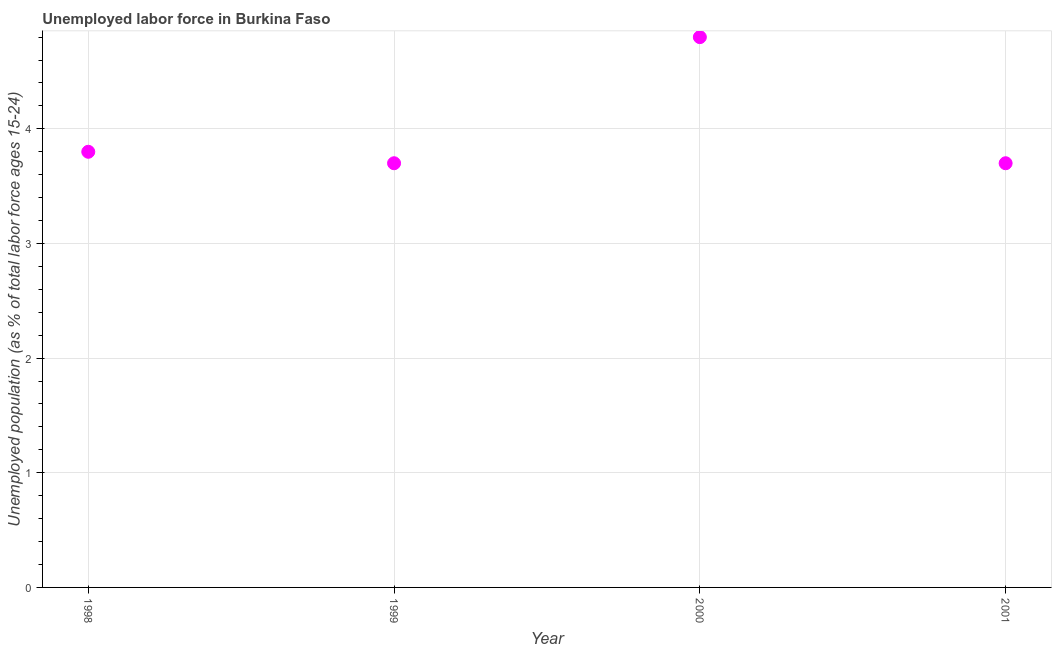What is the total unemployed youth population in 1998?
Keep it short and to the point. 3.8. Across all years, what is the maximum total unemployed youth population?
Offer a terse response. 4.8. Across all years, what is the minimum total unemployed youth population?
Your answer should be very brief. 3.7. In which year was the total unemployed youth population maximum?
Offer a very short reply. 2000. In which year was the total unemployed youth population minimum?
Ensure brevity in your answer.  1999. What is the sum of the total unemployed youth population?
Provide a short and direct response. 16. What is the average total unemployed youth population per year?
Ensure brevity in your answer.  4. What is the median total unemployed youth population?
Ensure brevity in your answer.  3.75. In how many years, is the total unemployed youth population greater than 0.6000000000000001 %?
Your response must be concise. 4. Do a majority of the years between 2001 and 1998 (inclusive) have total unemployed youth population greater than 1 %?
Provide a short and direct response. Yes. What is the ratio of the total unemployed youth population in 2000 to that in 2001?
Provide a short and direct response. 1.3. Is the difference between the total unemployed youth population in 1998 and 2001 greater than the difference between any two years?
Your response must be concise. No. What is the difference between the highest and the second highest total unemployed youth population?
Make the answer very short. 1. What is the difference between the highest and the lowest total unemployed youth population?
Your answer should be very brief. 1.1. How many dotlines are there?
Your answer should be very brief. 1. How many years are there in the graph?
Your response must be concise. 4. What is the difference between two consecutive major ticks on the Y-axis?
Offer a very short reply. 1. Does the graph contain any zero values?
Offer a terse response. No. Does the graph contain grids?
Your response must be concise. Yes. What is the title of the graph?
Provide a succinct answer. Unemployed labor force in Burkina Faso. What is the label or title of the Y-axis?
Offer a terse response. Unemployed population (as % of total labor force ages 15-24). What is the Unemployed population (as % of total labor force ages 15-24) in 1998?
Give a very brief answer. 3.8. What is the Unemployed population (as % of total labor force ages 15-24) in 1999?
Your answer should be very brief. 3.7. What is the Unemployed population (as % of total labor force ages 15-24) in 2000?
Give a very brief answer. 4.8. What is the Unemployed population (as % of total labor force ages 15-24) in 2001?
Your response must be concise. 3.7. What is the difference between the Unemployed population (as % of total labor force ages 15-24) in 1998 and 1999?
Offer a very short reply. 0.1. What is the difference between the Unemployed population (as % of total labor force ages 15-24) in 1998 and 2000?
Your response must be concise. -1. What is the difference between the Unemployed population (as % of total labor force ages 15-24) in 1998 and 2001?
Provide a succinct answer. 0.1. What is the difference between the Unemployed population (as % of total labor force ages 15-24) in 1999 and 2000?
Give a very brief answer. -1.1. What is the difference between the Unemployed population (as % of total labor force ages 15-24) in 1999 and 2001?
Your answer should be very brief. 0. What is the ratio of the Unemployed population (as % of total labor force ages 15-24) in 1998 to that in 2000?
Provide a succinct answer. 0.79. What is the ratio of the Unemployed population (as % of total labor force ages 15-24) in 1998 to that in 2001?
Offer a terse response. 1.03. What is the ratio of the Unemployed population (as % of total labor force ages 15-24) in 1999 to that in 2000?
Provide a succinct answer. 0.77. What is the ratio of the Unemployed population (as % of total labor force ages 15-24) in 2000 to that in 2001?
Provide a succinct answer. 1.3. 